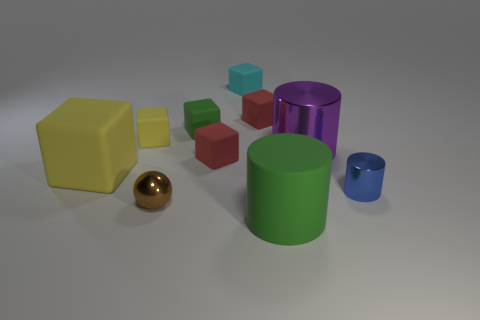What is the color of the large cylinder that is the same material as the blue thing?
Give a very brief answer. Purple. There is a blue cylinder; does it have the same size as the yellow cube that is in front of the big purple metal object?
Provide a succinct answer. No. There is a green object behind the big matte cylinder on the right side of the small rubber block that is left of the small brown metal sphere; what size is it?
Give a very brief answer. Small. How many matte things are big cyan blocks or blue cylinders?
Offer a very short reply. 0. What color is the metallic cylinder that is right of the big purple cylinder?
Keep it short and to the point. Blue. What is the shape of the metallic object that is the same size as the blue cylinder?
Ensure brevity in your answer.  Sphere. There is a big block; is its color the same as the tiny matte block left of the small green matte thing?
Offer a very short reply. Yes. What number of objects are tiny objects left of the metallic ball or things on the right side of the big yellow object?
Provide a short and direct response. 9. There is a yellow cube that is the same size as the purple shiny object; what is it made of?
Provide a short and direct response. Rubber. What number of other objects are the same material as the tiny green thing?
Your answer should be compact. 6. 